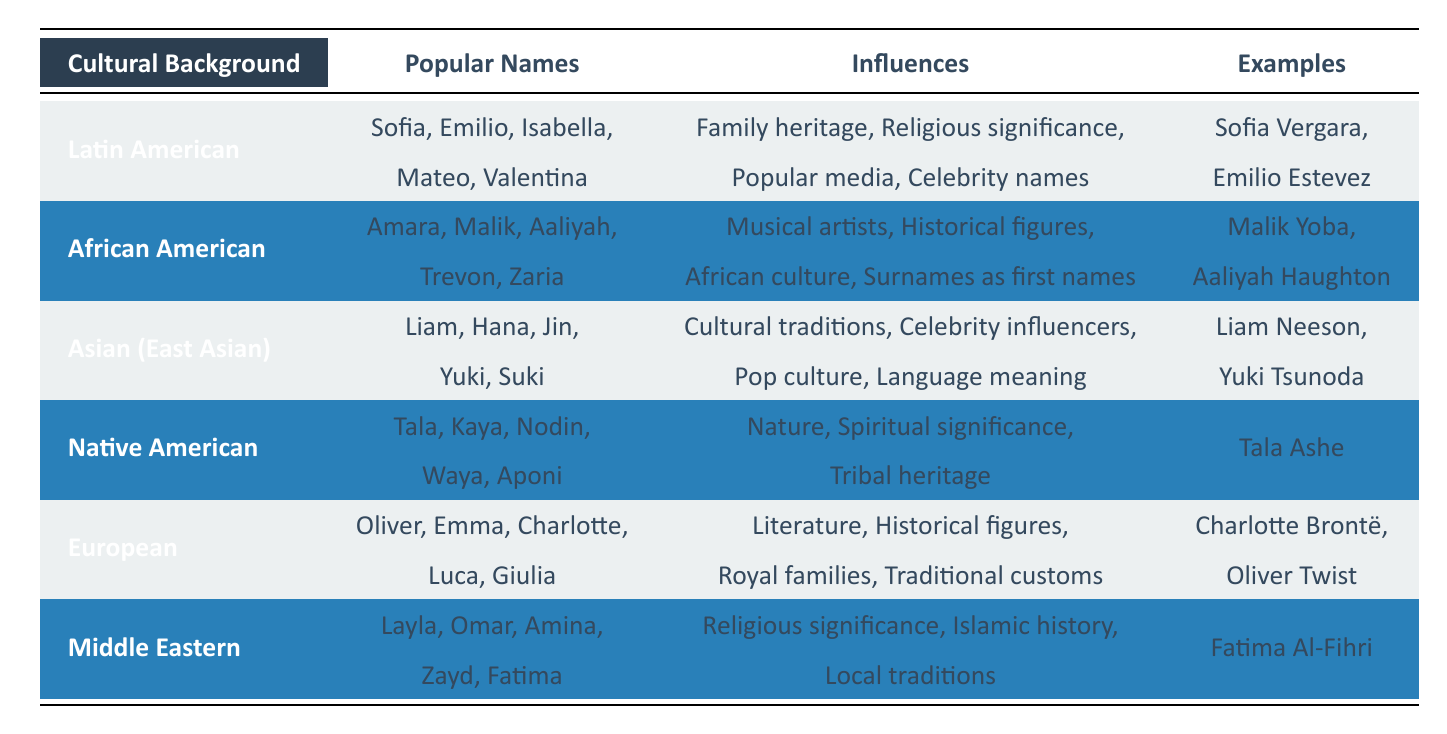What are some popular names in the Latin American cultural background? According to the table, the popular names in the Latin American cultural background include Sofia, Emilio, Isabella, Mateo, and Valentina.
Answer: Sofia, Emilio, Isabella, Mateo, Valentina Is the name "Malik" influenced by historical figures? The table lists "Historical figures" as one of the influences for African American names, and "Malik" is included in the popular names for this cultural background. Therefore, the answer is yes.
Answer: Yes Which cultural background has "Literature" as an influence for baby names? The table states that the European cultural background cites "Literature" as an influence. The popular names under this category include Oliver, Emma, Charlotte, Luca, and Giulia.
Answer: European Compare the number of popular names from African American and Middle Eastern backgrounds. The African American background has 5 popular names (Amara, Malik, Aaliyah, Trevon, Zaria) and the Middle Eastern background also has 5 popular names (Layla, Omar, Amina, Zayd, Fatima). Therefore, both have the same number of popular names.
Answer: They both have 5 names Do any popular names in the Native American cultural background have spiritual significance as an influence? The influences for Native American names include "Spiritual significance." Since some names like Tala and Kaya could be considered significant on a spiritual level, the answer is yes.
Answer: Yes Which names are influenced by celebrity names according to the table? In the Latin American cultural background, the table includes "Celebrity names" as an influence, though specific celebrity names are not listed under popular names. Thus, no specific names from the table can be cited.
Answer: No specific names listed What common themes can be drawn from the influences listed across different cultural backgrounds? When analyzing the influences, common themes include the impact of cultural heritage, religious beliefs, and significant figures, either in history or contemporary settings, that shape name choices. These elements appear in multiple cultural backgrounds listed in the table.
Answer: Cultural heritage, religious beliefs, significant figures Are there more names reflecting nature in the influences from Native American culture compared to Asian culture? The Native American cultural background has "Nature" listed as one of its influences along with 5 names, while the Asian cultural background references "Cultural traditions" and "Celebrity influencers," but does not explicitly mention nature. Therefore, names reflecting nature are primarily present in Native American culture.
Answer: Yes, more in Native American culture 